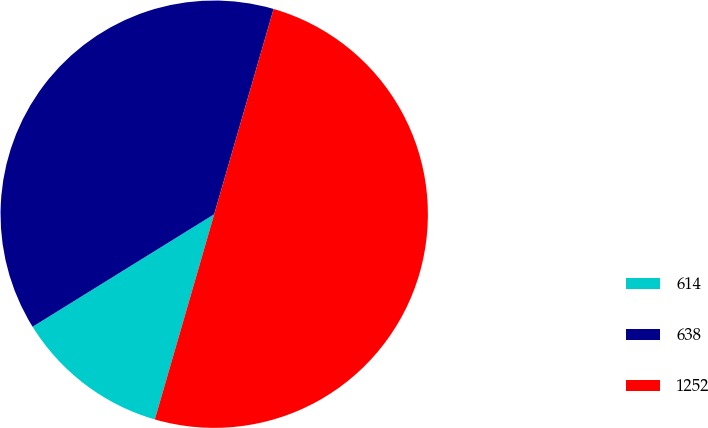<chart> <loc_0><loc_0><loc_500><loc_500><pie_chart><fcel>614<fcel>638<fcel>1252<nl><fcel>11.69%<fcel>38.31%<fcel>50.0%<nl></chart> 